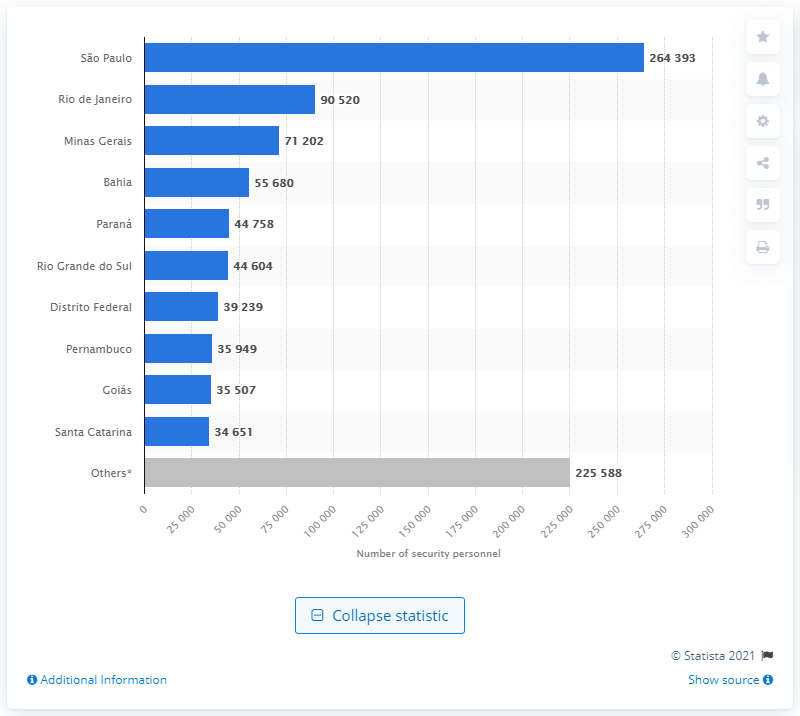Mention a couple of crucial points in this snapshot. Rio de Janeiro had the highest number of private security workers in Brazil in 2018, among all the states. 